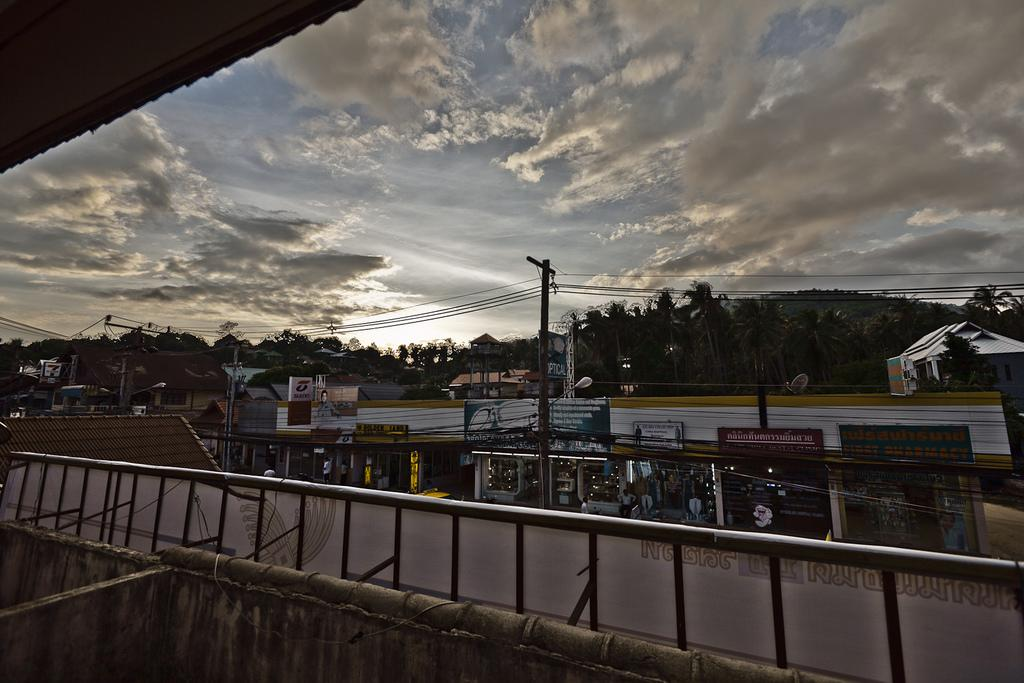What is located in the front of the image? In the front of the image, there is a wall, a hoarding, stores, boards, poles, people, lights, beams, houses, trees, and various objects. Can you describe the hoarding in the front of the image? The hoarding in the front of the image is a large advertising or promotional display. What type of structures can be seen in the front of the image? In the front of the image, there are stores, houses, and a wall. What is the weather like in the image? The sky is visible in the background of the image, and it is cloudy. What type of watch can be seen on the fang of the animal in the image? There are no animals or watches present in the image. What is the value of the fang in the image? There are no fangs or any indication of value in the image. 